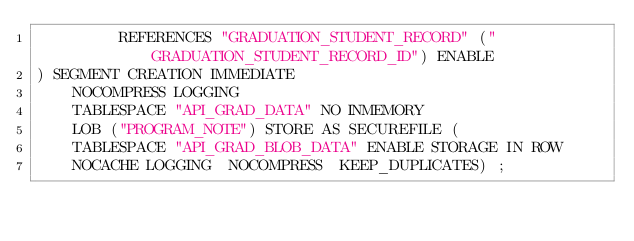<code> <loc_0><loc_0><loc_500><loc_500><_SQL_>         REFERENCES "GRADUATION_STUDENT_RECORD" ("GRADUATION_STUDENT_RECORD_ID") ENABLE
) SEGMENT CREATION IMMEDIATE
    NOCOMPRESS LOGGING
    TABLESPACE "API_GRAD_DATA" NO INMEMORY
    LOB ("PROGRAM_NOTE") STORE AS SECUREFILE (
    TABLESPACE "API_GRAD_BLOB_DATA" ENABLE STORAGE IN ROW
    NOCACHE LOGGING  NOCOMPRESS  KEEP_DUPLICATES) ;

</code> 